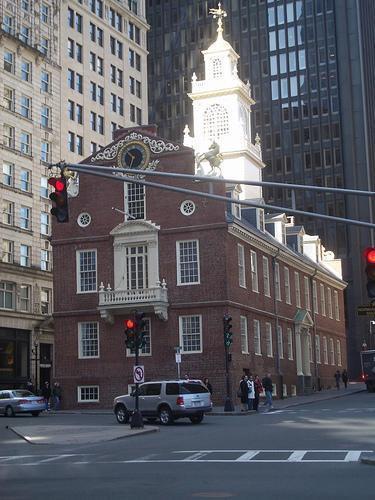How many vehicles are visible?
Give a very brief answer. 3. How many tires are visible in between the two greyhound dog logos?
Give a very brief answer. 0. 